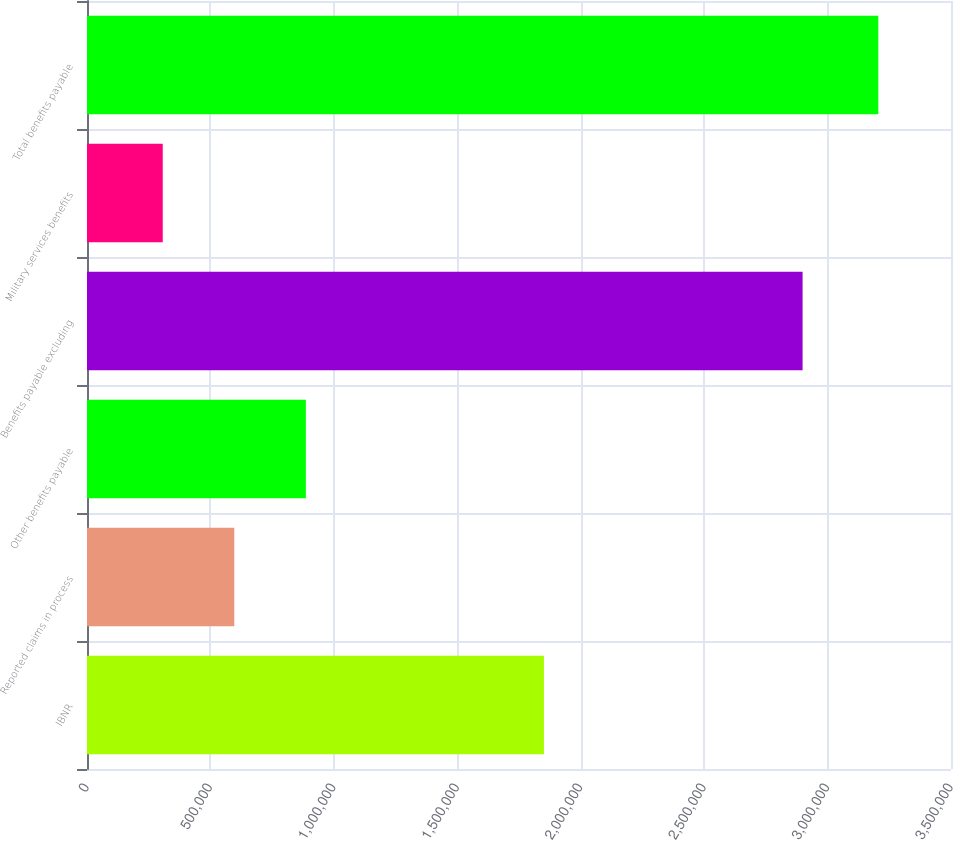Convert chart to OTSL. <chart><loc_0><loc_0><loc_500><loc_500><bar_chart><fcel>IBNR<fcel>Reported claims in process<fcel>Other benefits payable<fcel>Benefits payable excluding<fcel>Military services benefits<fcel>Total benefits payable<nl><fcel>1.85105e+06<fcel>596675<fcel>886553<fcel>2.89878e+06<fcel>306797<fcel>3.20558e+06<nl></chart> 